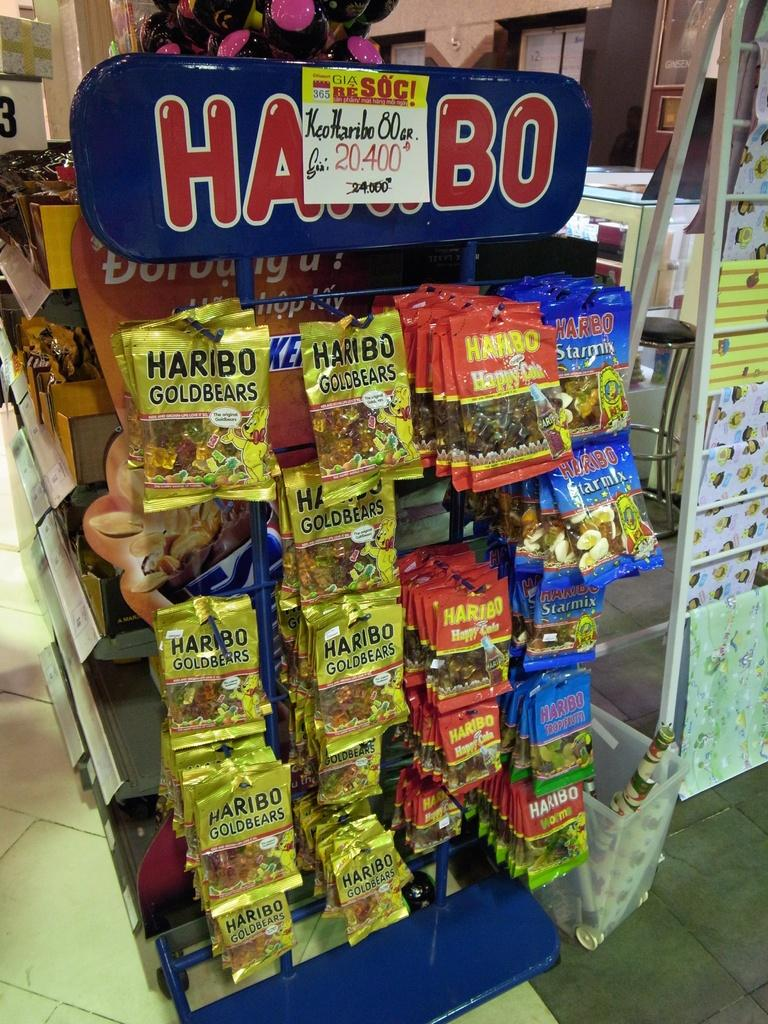Provide a one-sentence caption for the provided image. A display showing many packs of Haribo Goldbears. 